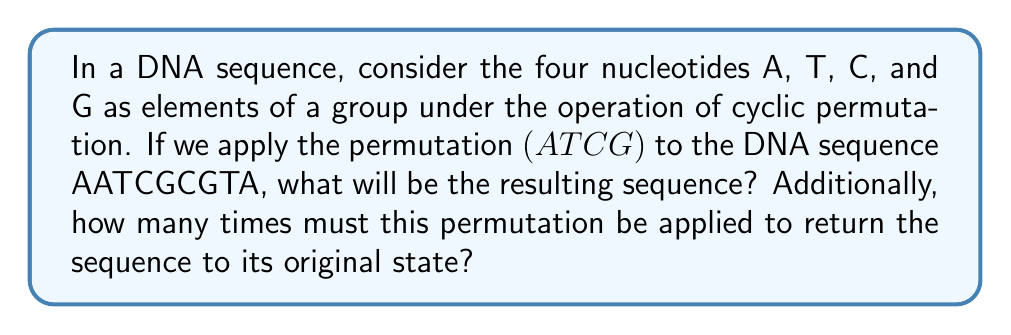Help me with this question. Let's approach this step-by-step:

1) The permutation $(ATCG)$ means that:
   A → T
   T → C
   C → G
   G → A

2) Applying this to each nucleotide in the sequence AATCGCGTA:
   A → T
   A → T
   T → C
   C → G
   G → A
   C → G
   G → A
   T → C
   A → T

3) Therefore, the resulting sequence is TTCGAGACT.

4) To determine how many times this permutation must be applied to return to the original sequence, we need to find the order of the permutation.

5) The order of a cyclic permutation of $n$ elements is always $n$. In this case, we have 4 elements (A, T, C, G), so the order is 4.

6) This means that:
   $(ATCG)^1$ = (ATCG)
   $(ATCG)^2$ = (ACGT)
   $(ATCG)^3$ = (AGtc)
   $(ATCG)^4$ = (ATCG)^0 = identity permutation

7) Therefore, applying the permutation 4 times will return any sequence to its original state.

This concept is related to group theory, where the set of permutations forms a group under composition. The cyclic group generated by $(ATCG)$ is isomorphic to $\mathbb{Z}_4$, the cyclic group of order 4.
Answer: The resulting sequence is TTCGAGACT. The permutation must be applied 4 times to return the sequence to its original state. 